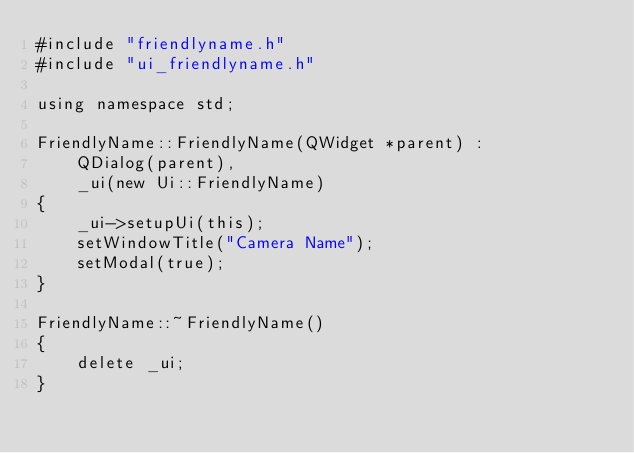<code> <loc_0><loc_0><loc_500><loc_500><_C++_>#include "friendlyname.h"
#include "ui_friendlyname.h"

using namespace std;

FriendlyName::FriendlyName(QWidget *parent) :
    QDialog(parent),
    _ui(new Ui::FriendlyName)
{
    _ui->setupUi(this);
    setWindowTitle("Camera Name");
    setModal(true);
}

FriendlyName::~FriendlyName()
{
    delete _ui;
}
</code> 